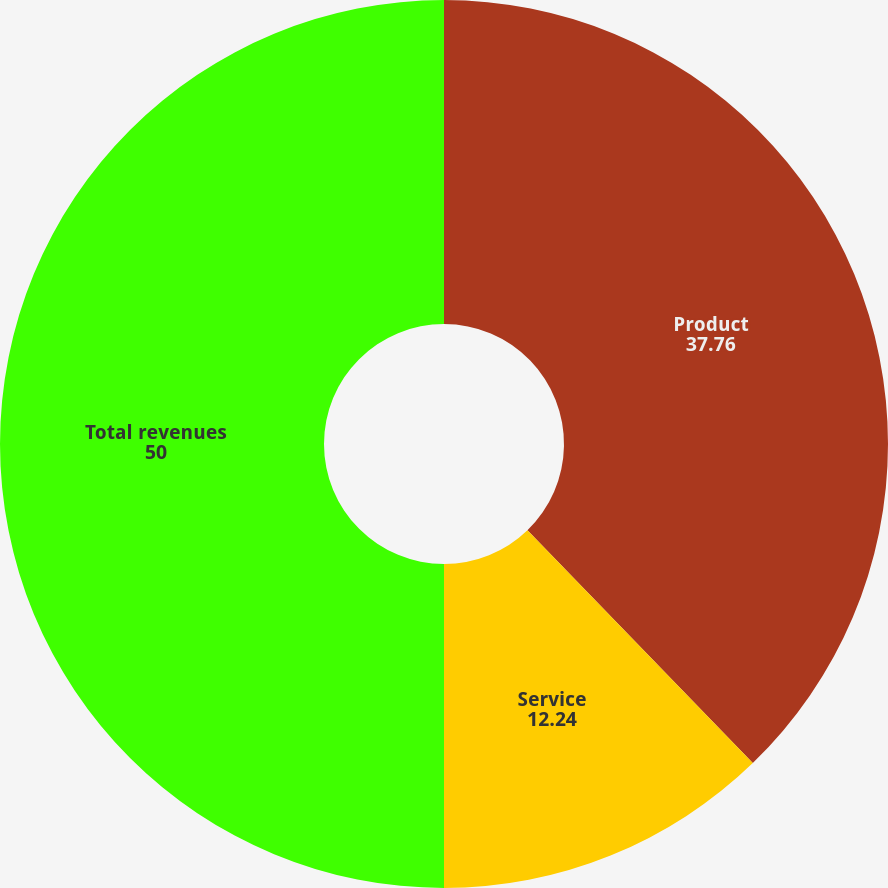Convert chart. <chart><loc_0><loc_0><loc_500><loc_500><pie_chart><fcel>Product<fcel>Service<fcel>Total revenues<nl><fcel>37.76%<fcel>12.24%<fcel>50.0%<nl></chart> 